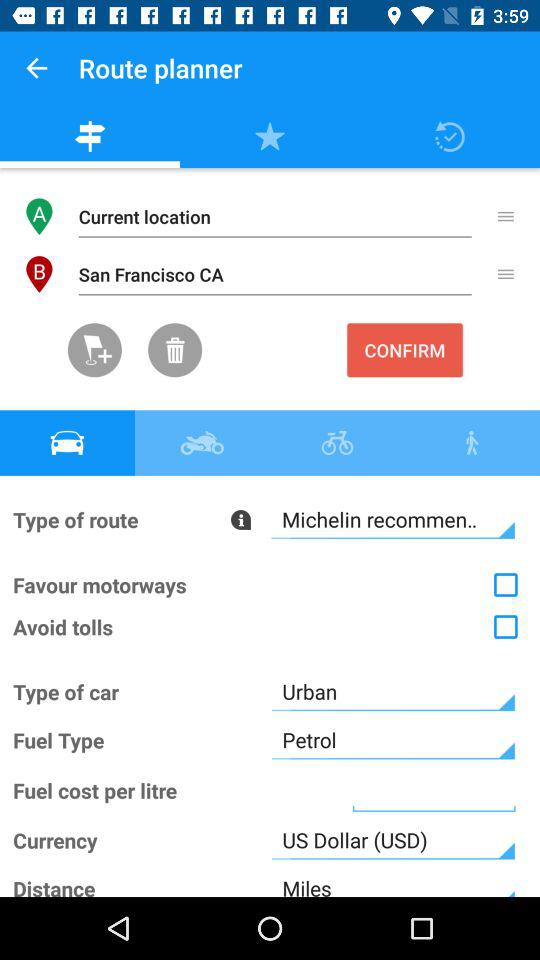How many check boxes are there on the screen?
Answer the question using a single word or phrase. 2 